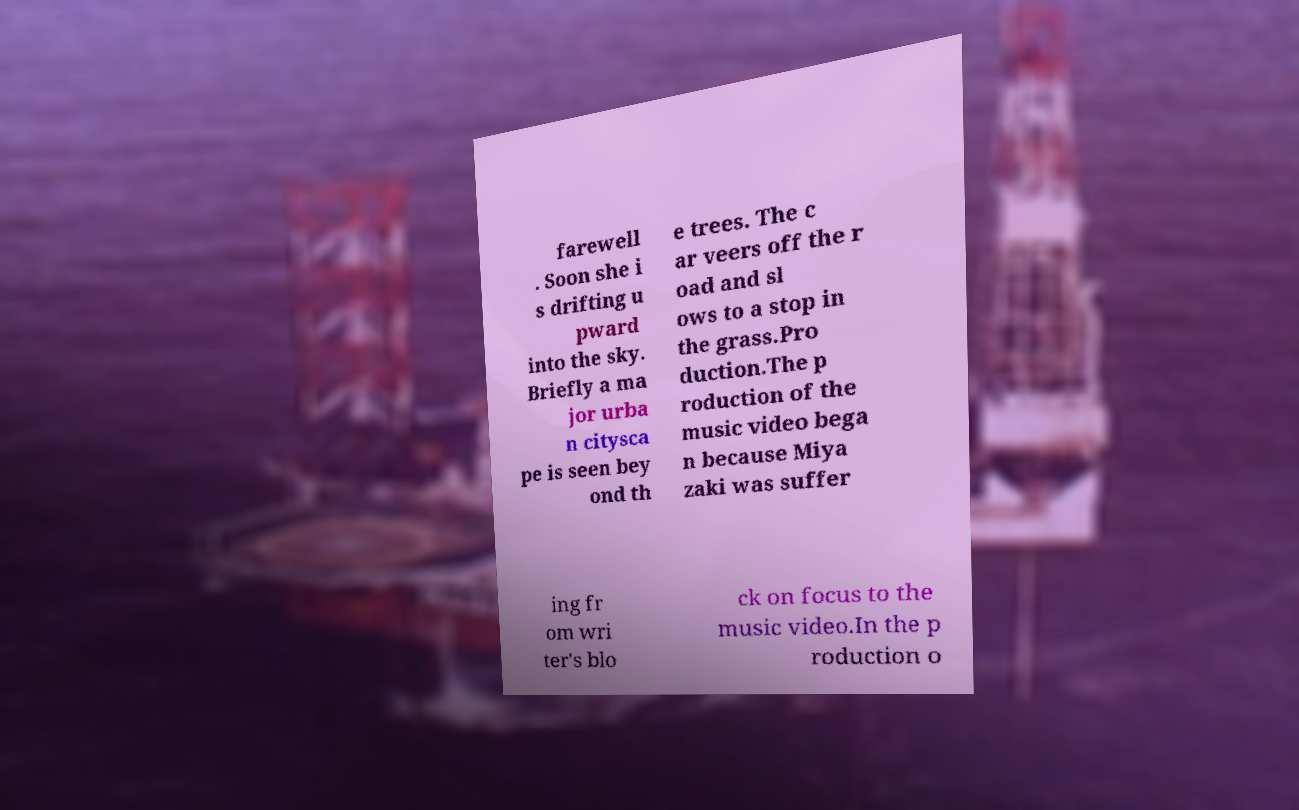Can you accurately transcribe the text from the provided image for me? farewell . Soon she i s drifting u pward into the sky. Briefly a ma jor urba n citysca pe is seen bey ond th e trees. The c ar veers off the r oad and sl ows to a stop in the grass.Pro duction.The p roduction of the music video bega n because Miya zaki was suffer ing fr om wri ter's blo ck on focus to the music video.In the p roduction o 